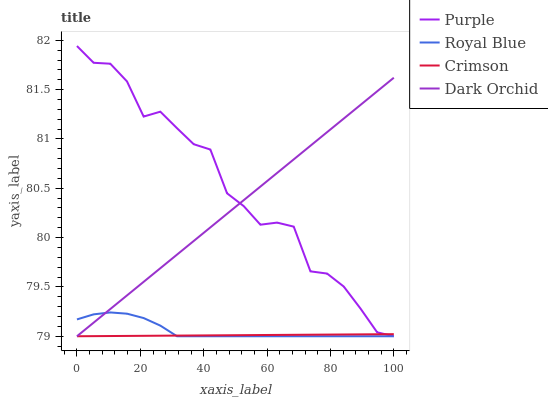Does Crimson have the minimum area under the curve?
Answer yes or no. Yes. Does Purple have the maximum area under the curve?
Answer yes or no. Yes. Does Royal Blue have the minimum area under the curve?
Answer yes or no. No. Does Royal Blue have the maximum area under the curve?
Answer yes or no. No. Is Dark Orchid the smoothest?
Answer yes or no. Yes. Is Purple the roughest?
Answer yes or no. Yes. Is Royal Blue the smoothest?
Answer yes or no. No. Is Royal Blue the roughest?
Answer yes or no. No. Does Purple have the lowest value?
Answer yes or no. Yes. Does Purple have the highest value?
Answer yes or no. Yes. Does Royal Blue have the highest value?
Answer yes or no. No. Does Purple intersect Dark Orchid?
Answer yes or no. Yes. Is Purple less than Dark Orchid?
Answer yes or no. No. Is Purple greater than Dark Orchid?
Answer yes or no. No. 